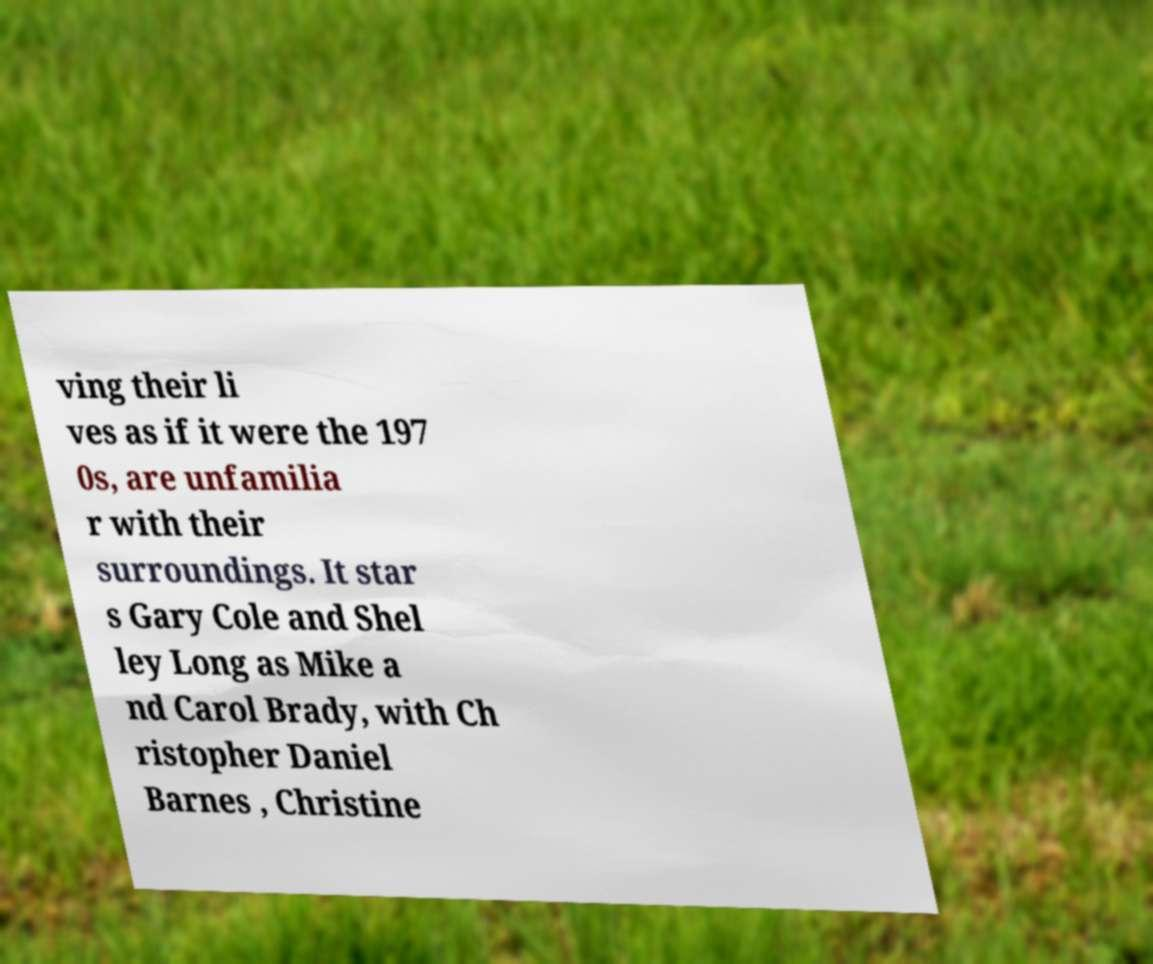Can you accurately transcribe the text from the provided image for me? ving their li ves as if it were the 197 0s, are unfamilia r with their surroundings. It star s Gary Cole and Shel ley Long as Mike a nd Carol Brady, with Ch ristopher Daniel Barnes , Christine 